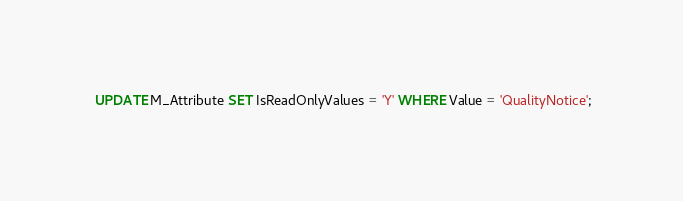<code> <loc_0><loc_0><loc_500><loc_500><_SQL_>

 UPDATE M_Attribute SET IsReadOnlyValues = 'Y' WHERE Value = 'QualityNotice';</code> 